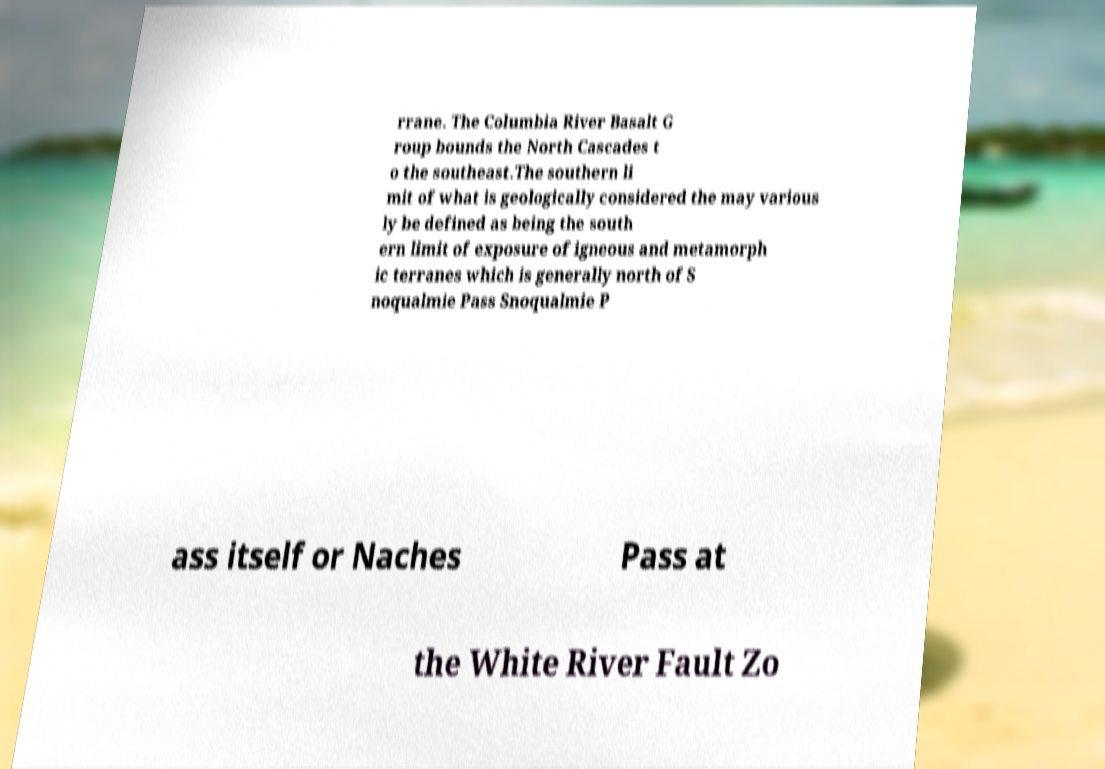Please identify and transcribe the text found in this image. rrane. The Columbia River Basalt G roup bounds the North Cascades t o the southeast.The southern li mit of what is geologically considered the may various ly be defined as being the south ern limit of exposure of igneous and metamorph ic terranes which is generally north of S noqualmie Pass Snoqualmie P ass itself or Naches Pass at the White River Fault Zo 